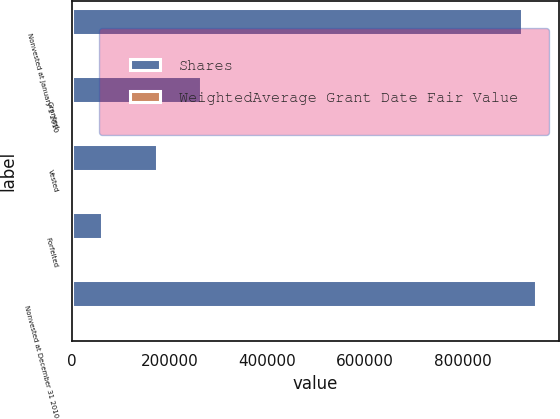<chart> <loc_0><loc_0><loc_500><loc_500><stacked_bar_chart><ecel><fcel>Nonvested at January 1 2010<fcel>Granted<fcel>Vested<fcel>Forfeited<fcel>Nonvested at December 31 2010<nl><fcel>Shares<fcel>920599<fcel>264915<fcel>173703<fcel>61714<fcel>950097<nl><fcel>WeightedAverage Grant Date Fair Value<fcel>29.58<fcel>31.9<fcel>32.38<fcel>27.89<fcel>29.83<nl></chart> 